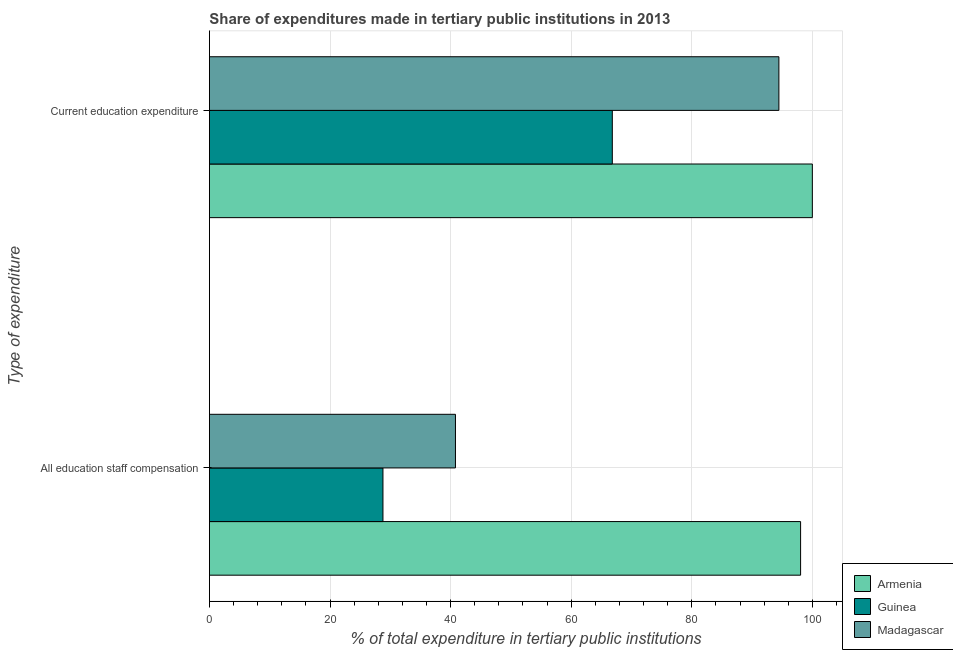How many different coloured bars are there?
Your response must be concise. 3. How many groups of bars are there?
Your answer should be very brief. 2. Are the number of bars on each tick of the Y-axis equal?
Your answer should be very brief. Yes. How many bars are there on the 2nd tick from the bottom?
Your answer should be very brief. 3. What is the label of the 1st group of bars from the top?
Your answer should be very brief. Current education expenditure. What is the expenditure in staff compensation in Armenia?
Make the answer very short. 98.05. Across all countries, what is the maximum expenditure in staff compensation?
Your answer should be very brief. 98.05. Across all countries, what is the minimum expenditure in staff compensation?
Provide a succinct answer. 28.78. In which country was the expenditure in staff compensation maximum?
Keep it short and to the point. Armenia. In which country was the expenditure in staff compensation minimum?
Keep it short and to the point. Guinea. What is the total expenditure in staff compensation in the graph?
Offer a very short reply. 167.64. What is the difference between the expenditure in staff compensation in Guinea and that in Madagascar?
Provide a short and direct response. -12.03. What is the difference between the expenditure in staff compensation in Armenia and the expenditure in education in Madagascar?
Provide a short and direct response. 3.6. What is the average expenditure in staff compensation per country?
Give a very brief answer. 55.88. What is the difference between the expenditure in education and expenditure in staff compensation in Madagascar?
Make the answer very short. 53.64. In how many countries, is the expenditure in staff compensation greater than 68 %?
Make the answer very short. 1. What is the ratio of the expenditure in staff compensation in Guinea to that in Armenia?
Make the answer very short. 0.29. What does the 2nd bar from the top in Current education expenditure represents?
Offer a terse response. Guinea. What does the 2nd bar from the bottom in All education staff compensation represents?
Keep it short and to the point. Guinea. How many bars are there?
Provide a succinct answer. 6. Are all the bars in the graph horizontal?
Your response must be concise. Yes. Are the values on the major ticks of X-axis written in scientific E-notation?
Offer a terse response. No. Does the graph contain any zero values?
Your response must be concise. No. How many legend labels are there?
Keep it short and to the point. 3. What is the title of the graph?
Your response must be concise. Share of expenditures made in tertiary public institutions in 2013. What is the label or title of the X-axis?
Give a very brief answer. % of total expenditure in tertiary public institutions. What is the label or title of the Y-axis?
Your answer should be very brief. Type of expenditure. What is the % of total expenditure in tertiary public institutions of Armenia in All education staff compensation?
Give a very brief answer. 98.05. What is the % of total expenditure in tertiary public institutions of Guinea in All education staff compensation?
Ensure brevity in your answer.  28.78. What is the % of total expenditure in tertiary public institutions of Madagascar in All education staff compensation?
Give a very brief answer. 40.81. What is the % of total expenditure in tertiary public institutions of Armenia in Current education expenditure?
Keep it short and to the point. 100. What is the % of total expenditure in tertiary public institutions in Guinea in Current education expenditure?
Offer a terse response. 66.82. What is the % of total expenditure in tertiary public institutions in Madagascar in Current education expenditure?
Offer a terse response. 94.45. Across all Type of expenditure, what is the maximum % of total expenditure in tertiary public institutions in Guinea?
Your response must be concise. 66.82. Across all Type of expenditure, what is the maximum % of total expenditure in tertiary public institutions of Madagascar?
Offer a terse response. 94.45. Across all Type of expenditure, what is the minimum % of total expenditure in tertiary public institutions in Armenia?
Provide a short and direct response. 98.05. Across all Type of expenditure, what is the minimum % of total expenditure in tertiary public institutions in Guinea?
Offer a terse response. 28.78. Across all Type of expenditure, what is the minimum % of total expenditure in tertiary public institutions in Madagascar?
Provide a short and direct response. 40.81. What is the total % of total expenditure in tertiary public institutions of Armenia in the graph?
Provide a short and direct response. 198.05. What is the total % of total expenditure in tertiary public institutions in Guinea in the graph?
Your answer should be compact. 95.61. What is the total % of total expenditure in tertiary public institutions in Madagascar in the graph?
Offer a very short reply. 135.26. What is the difference between the % of total expenditure in tertiary public institutions of Armenia in All education staff compensation and that in Current education expenditure?
Provide a short and direct response. -1.95. What is the difference between the % of total expenditure in tertiary public institutions in Guinea in All education staff compensation and that in Current education expenditure?
Provide a succinct answer. -38.04. What is the difference between the % of total expenditure in tertiary public institutions in Madagascar in All education staff compensation and that in Current education expenditure?
Your answer should be very brief. -53.64. What is the difference between the % of total expenditure in tertiary public institutions in Armenia in All education staff compensation and the % of total expenditure in tertiary public institutions in Guinea in Current education expenditure?
Your answer should be compact. 31.23. What is the difference between the % of total expenditure in tertiary public institutions of Armenia in All education staff compensation and the % of total expenditure in tertiary public institutions of Madagascar in Current education expenditure?
Make the answer very short. 3.6. What is the difference between the % of total expenditure in tertiary public institutions in Guinea in All education staff compensation and the % of total expenditure in tertiary public institutions in Madagascar in Current education expenditure?
Provide a succinct answer. -65.67. What is the average % of total expenditure in tertiary public institutions of Armenia per Type of expenditure?
Your response must be concise. 99.03. What is the average % of total expenditure in tertiary public institutions in Guinea per Type of expenditure?
Your response must be concise. 47.8. What is the average % of total expenditure in tertiary public institutions in Madagascar per Type of expenditure?
Provide a succinct answer. 67.63. What is the difference between the % of total expenditure in tertiary public institutions in Armenia and % of total expenditure in tertiary public institutions in Guinea in All education staff compensation?
Ensure brevity in your answer.  69.27. What is the difference between the % of total expenditure in tertiary public institutions of Armenia and % of total expenditure in tertiary public institutions of Madagascar in All education staff compensation?
Offer a very short reply. 57.24. What is the difference between the % of total expenditure in tertiary public institutions of Guinea and % of total expenditure in tertiary public institutions of Madagascar in All education staff compensation?
Make the answer very short. -12.03. What is the difference between the % of total expenditure in tertiary public institutions in Armenia and % of total expenditure in tertiary public institutions in Guinea in Current education expenditure?
Your answer should be compact. 33.18. What is the difference between the % of total expenditure in tertiary public institutions in Armenia and % of total expenditure in tertiary public institutions in Madagascar in Current education expenditure?
Provide a succinct answer. 5.55. What is the difference between the % of total expenditure in tertiary public institutions of Guinea and % of total expenditure in tertiary public institutions of Madagascar in Current education expenditure?
Make the answer very short. -27.63. What is the ratio of the % of total expenditure in tertiary public institutions in Armenia in All education staff compensation to that in Current education expenditure?
Make the answer very short. 0.98. What is the ratio of the % of total expenditure in tertiary public institutions of Guinea in All education staff compensation to that in Current education expenditure?
Offer a terse response. 0.43. What is the ratio of the % of total expenditure in tertiary public institutions of Madagascar in All education staff compensation to that in Current education expenditure?
Your answer should be compact. 0.43. What is the difference between the highest and the second highest % of total expenditure in tertiary public institutions of Armenia?
Offer a very short reply. 1.95. What is the difference between the highest and the second highest % of total expenditure in tertiary public institutions of Guinea?
Your answer should be compact. 38.04. What is the difference between the highest and the second highest % of total expenditure in tertiary public institutions in Madagascar?
Your answer should be compact. 53.64. What is the difference between the highest and the lowest % of total expenditure in tertiary public institutions in Armenia?
Your answer should be very brief. 1.95. What is the difference between the highest and the lowest % of total expenditure in tertiary public institutions in Guinea?
Your answer should be very brief. 38.04. What is the difference between the highest and the lowest % of total expenditure in tertiary public institutions in Madagascar?
Provide a succinct answer. 53.64. 